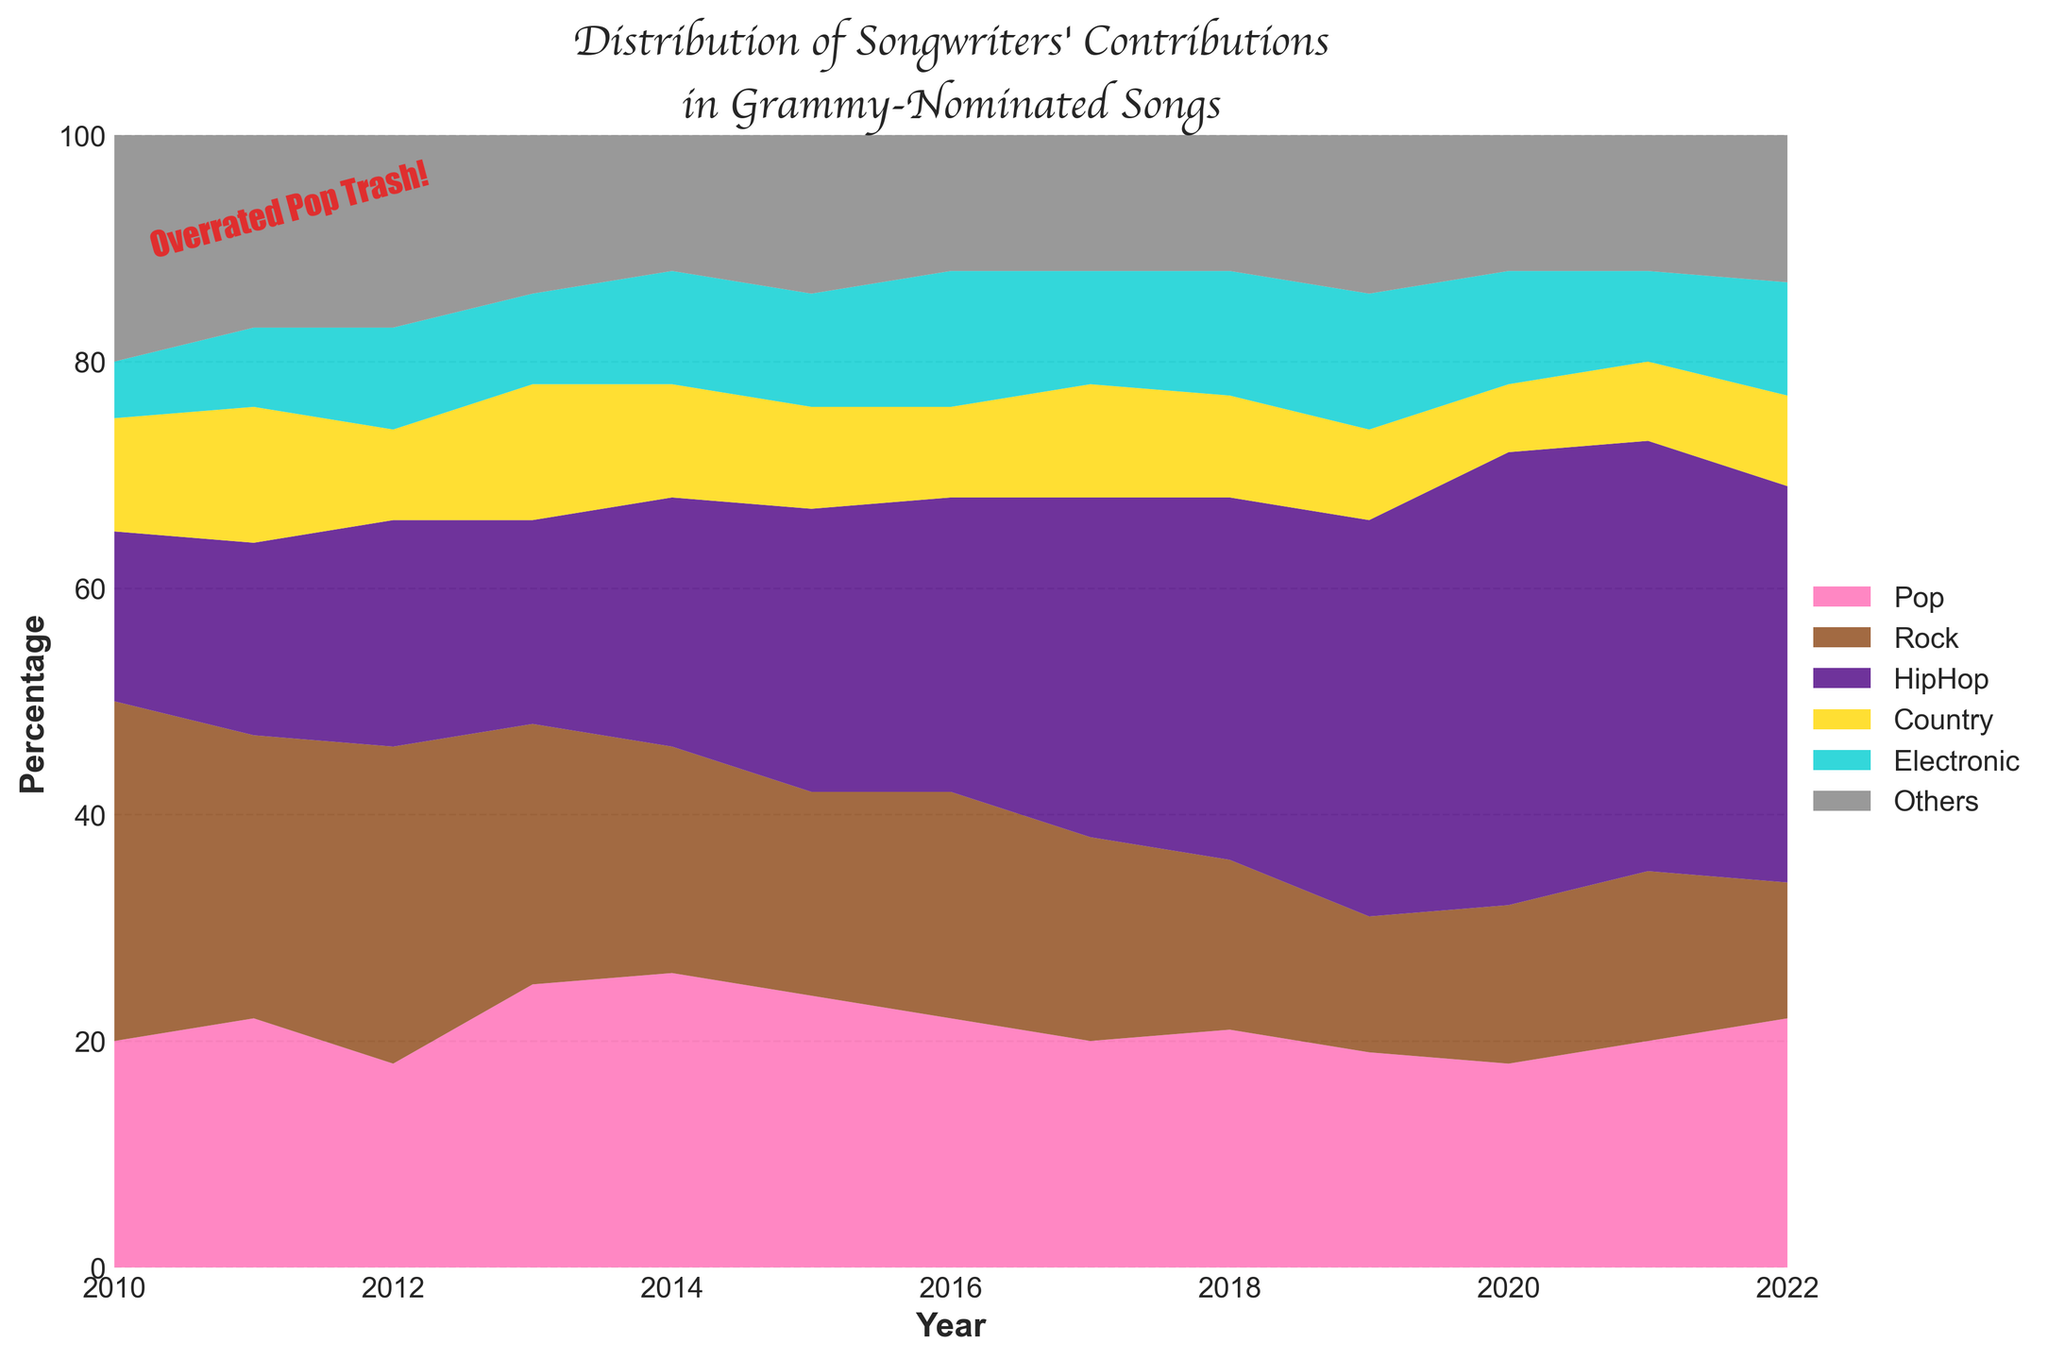what is the title of the chart? Looking at the top of the figure, the title is located in a bold cursive font that clearly states the purpose of the chart.
Answer: Distribution of Songwriters' Contributions in Grammy-Nominated Songs which year shows the highest percentage of Hip Hop contributions? The figure uses different colors to represent genres, and Hip Hop is shown with indigo. By looking at the indigo area, it peaks around 2020.
Answer: 2020 compare the contributions of Pop and Rock in 2010. Which one is higher? Pop is shown in pink and Rock in brown. By comparing these two areas in 2010, Rock has a larger area than Pop.
Answer: Rock how did Country contributions change from 2012 to 2014? Locate the gold area representing Country, starting at 8 in 2012, changing to 12 in 2013, and then to 10 in 2014, showing an overall increase then slight decrease.
Answer: Increased then decreased what is the smallest contribution percentage for Electronic music over the years? The chart uses teal to show Electronic music. To find the smallest, follow the teal area across years, identifying the lowest point, which is in 2010.
Answer: 5% which genre saw the most significant upward trend between 2010 and 2022? Analyze the slopes of the different colored areas over time. The indigo section representing Hip Hop grows substantially.
Answer: Hip Hop calculate the average percentage of Rock contributions from 2010 to 2022. For each year, note Rock's percentage and sum them. Then, divide by the number of years (13). (30+25+28+23+20+18+20+18+15+12+14+15+12)/13 = 19.88
Answer: 19.88% in which year did the "Others" category have its highest contribution? "Others" is shown in gray. Follow the gray area across the graph to see the highest point, which is in 2010.
Answer: 2010 compare the total contributions of Pop from the start to the end of the time period. Look at the pink area in 2010 and 2022. It starts at 20 in 2010 and ends at 22 in 2022, showing a slight increase.
Answer: Increased what is the primary trend in the distribution of songwriters' contributions in Grammy-nominated songs over the years? By observing the overall shape and movement of all areas, especially noting the rapid rise of Hip Hop and the fluctuating yet somewhat stable patterns in other genres, we can conclude that Hip Hop's influence has significantly increased.
Answer: Increase in Hip Hop 